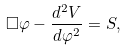Convert formula to latex. <formula><loc_0><loc_0><loc_500><loc_500>\Box \varphi - \frac { d ^ { 2 } V } { d \varphi ^ { 2 } } = S ,</formula> 